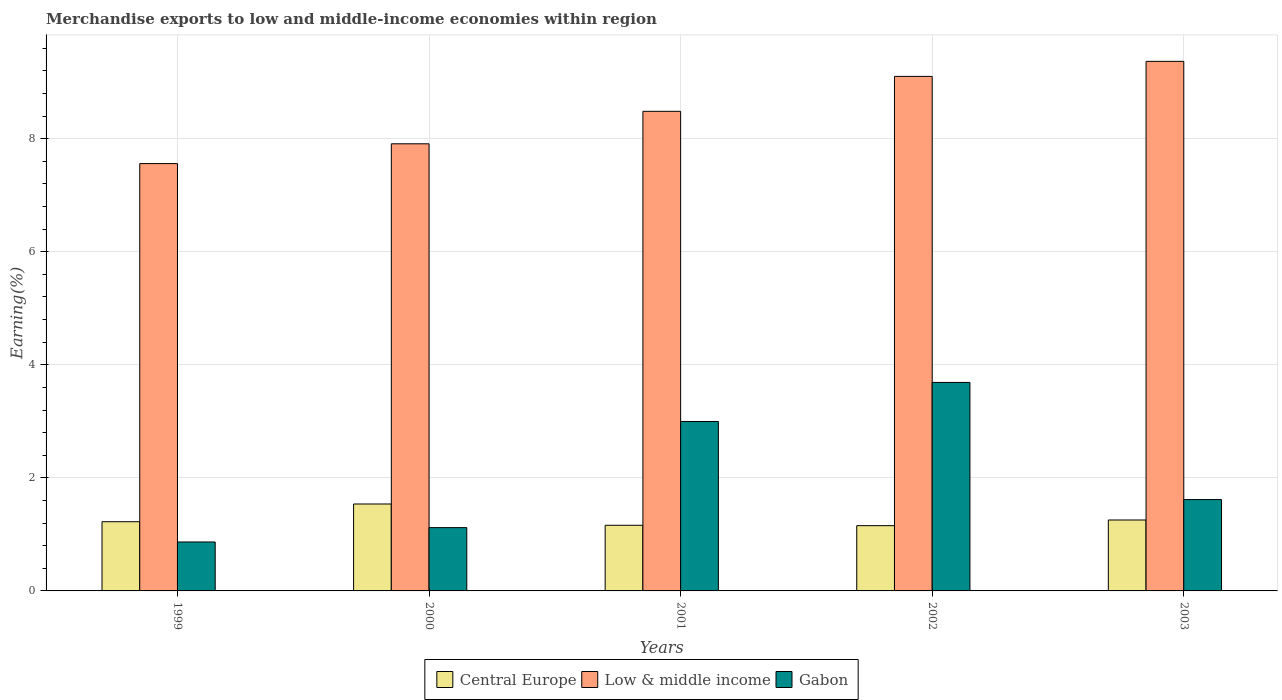How many groups of bars are there?
Your response must be concise. 5. Are the number of bars per tick equal to the number of legend labels?
Give a very brief answer. Yes. Are the number of bars on each tick of the X-axis equal?
Make the answer very short. Yes. How many bars are there on the 1st tick from the left?
Make the answer very short. 3. How many bars are there on the 3rd tick from the right?
Offer a terse response. 3. What is the label of the 1st group of bars from the left?
Keep it short and to the point. 1999. What is the percentage of amount earned from merchandise exports in Gabon in 1999?
Provide a short and direct response. 0.87. Across all years, what is the maximum percentage of amount earned from merchandise exports in Low & middle income?
Give a very brief answer. 9.37. Across all years, what is the minimum percentage of amount earned from merchandise exports in Gabon?
Provide a short and direct response. 0.87. In which year was the percentage of amount earned from merchandise exports in Gabon minimum?
Provide a short and direct response. 1999. What is the total percentage of amount earned from merchandise exports in Low & middle income in the graph?
Your answer should be compact. 42.42. What is the difference between the percentage of amount earned from merchandise exports in Low & middle income in 1999 and that in 2003?
Provide a succinct answer. -1.81. What is the difference between the percentage of amount earned from merchandise exports in Gabon in 2002 and the percentage of amount earned from merchandise exports in Central Europe in 1999?
Offer a terse response. 2.46. What is the average percentage of amount earned from merchandise exports in Low & middle income per year?
Offer a very short reply. 8.48. In the year 2000, what is the difference between the percentage of amount earned from merchandise exports in Low & middle income and percentage of amount earned from merchandise exports in Central Europe?
Give a very brief answer. 6.37. What is the ratio of the percentage of amount earned from merchandise exports in Gabon in 2000 to that in 2002?
Make the answer very short. 0.3. Is the percentage of amount earned from merchandise exports in Central Europe in 1999 less than that in 2000?
Make the answer very short. Yes. What is the difference between the highest and the second highest percentage of amount earned from merchandise exports in Central Europe?
Provide a short and direct response. 0.28. What is the difference between the highest and the lowest percentage of amount earned from merchandise exports in Gabon?
Provide a short and direct response. 2.82. What does the 1st bar from the right in 2003 represents?
Your answer should be compact. Gabon. Is it the case that in every year, the sum of the percentage of amount earned from merchandise exports in Central Europe and percentage of amount earned from merchandise exports in Low & middle income is greater than the percentage of amount earned from merchandise exports in Gabon?
Make the answer very short. Yes. How many bars are there?
Provide a succinct answer. 15. Does the graph contain grids?
Ensure brevity in your answer.  Yes. How many legend labels are there?
Give a very brief answer. 3. What is the title of the graph?
Keep it short and to the point. Merchandise exports to low and middle-income economies within region. Does "Bolivia" appear as one of the legend labels in the graph?
Ensure brevity in your answer.  No. What is the label or title of the X-axis?
Your answer should be compact. Years. What is the label or title of the Y-axis?
Provide a short and direct response. Earning(%). What is the Earning(%) in Central Europe in 1999?
Your response must be concise. 1.22. What is the Earning(%) in Low & middle income in 1999?
Your answer should be compact. 7.56. What is the Earning(%) of Gabon in 1999?
Give a very brief answer. 0.87. What is the Earning(%) of Central Europe in 2000?
Offer a very short reply. 1.54. What is the Earning(%) of Low & middle income in 2000?
Provide a succinct answer. 7.91. What is the Earning(%) in Gabon in 2000?
Give a very brief answer. 1.12. What is the Earning(%) in Central Europe in 2001?
Provide a short and direct response. 1.16. What is the Earning(%) of Low & middle income in 2001?
Offer a terse response. 8.48. What is the Earning(%) in Gabon in 2001?
Provide a succinct answer. 3. What is the Earning(%) in Central Europe in 2002?
Your answer should be very brief. 1.15. What is the Earning(%) of Low & middle income in 2002?
Provide a succinct answer. 9.1. What is the Earning(%) of Gabon in 2002?
Your response must be concise. 3.69. What is the Earning(%) in Central Europe in 2003?
Your response must be concise. 1.25. What is the Earning(%) in Low & middle income in 2003?
Keep it short and to the point. 9.37. What is the Earning(%) of Gabon in 2003?
Your response must be concise. 1.62. Across all years, what is the maximum Earning(%) in Central Europe?
Offer a very short reply. 1.54. Across all years, what is the maximum Earning(%) of Low & middle income?
Ensure brevity in your answer.  9.37. Across all years, what is the maximum Earning(%) of Gabon?
Offer a terse response. 3.69. Across all years, what is the minimum Earning(%) of Central Europe?
Provide a succinct answer. 1.15. Across all years, what is the minimum Earning(%) of Low & middle income?
Provide a short and direct response. 7.56. Across all years, what is the minimum Earning(%) of Gabon?
Provide a succinct answer. 0.87. What is the total Earning(%) in Central Europe in the graph?
Give a very brief answer. 6.33. What is the total Earning(%) in Low & middle income in the graph?
Your answer should be very brief. 42.42. What is the total Earning(%) of Gabon in the graph?
Your response must be concise. 10.29. What is the difference between the Earning(%) of Central Europe in 1999 and that in 2000?
Provide a succinct answer. -0.31. What is the difference between the Earning(%) of Low & middle income in 1999 and that in 2000?
Ensure brevity in your answer.  -0.35. What is the difference between the Earning(%) of Gabon in 1999 and that in 2000?
Provide a succinct answer. -0.25. What is the difference between the Earning(%) of Central Europe in 1999 and that in 2001?
Offer a terse response. 0.06. What is the difference between the Earning(%) in Low & middle income in 1999 and that in 2001?
Your answer should be compact. -0.92. What is the difference between the Earning(%) of Gabon in 1999 and that in 2001?
Your response must be concise. -2.13. What is the difference between the Earning(%) of Central Europe in 1999 and that in 2002?
Offer a terse response. 0.07. What is the difference between the Earning(%) of Low & middle income in 1999 and that in 2002?
Provide a short and direct response. -1.54. What is the difference between the Earning(%) of Gabon in 1999 and that in 2002?
Offer a terse response. -2.82. What is the difference between the Earning(%) of Central Europe in 1999 and that in 2003?
Your answer should be very brief. -0.03. What is the difference between the Earning(%) of Low & middle income in 1999 and that in 2003?
Offer a terse response. -1.81. What is the difference between the Earning(%) in Gabon in 1999 and that in 2003?
Offer a terse response. -0.75. What is the difference between the Earning(%) in Central Europe in 2000 and that in 2001?
Your answer should be very brief. 0.38. What is the difference between the Earning(%) in Low & middle income in 2000 and that in 2001?
Give a very brief answer. -0.57. What is the difference between the Earning(%) of Gabon in 2000 and that in 2001?
Provide a short and direct response. -1.88. What is the difference between the Earning(%) in Central Europe in 2000 and that in 2002?
Your answer should be very brief. 0.38. What is the difference between the Earning(%) in Low & middle income in 2000 and that in 2002?
Offer a very short reply. -1.19. What is the difference between the Earning(%) of Gabon in 2000 and that in 2002?
Give a very brief answer. -2.57. What is the difference between the Earning(%) of Central Europe in 2000 and that in 2003?
Provide a succinct answer. 0.28. What is the difference between the Earning(%) of Low & middle income in 2000 and that in 2003?
Keep it short and to the point. -1.46. What is the difference between the Earning(%) in Gabon in 2000 and that in 2003?
Your answer should be compact. -0.5. What is the difference between the Earning(%) of Central Europe in 2001 and that in 2002?
Your answer should be very brief. 0.01. What is the difference between the Earning(%) of Low & middle income in 2001 and that in 2002?
Your answer should be very brief. -0.62. What is the difference between the Earning(%) in Gabon in 2001 and that in 2002?
Your response must be concise. -0.69. What is the difference between the Earning(%) of Central Europe in 2001 and that in 2003?
Offer a very short reply. -0.09. What is the difference between the Earning(%) in Low & middle income in 2001 and that in 2003?
Provide a succinct answer. -0.88. What is the difference between the Earning(%) in Gabon in 2001 and that in 2003?
Your response must be concise. 1.38. What is the difference between the Earning(%) in Central Europe in 2002 and that in 2003?
Make the answer very short. -0.1. What is the difference between the Earning(%) of Low & middle income in 2002 and that in 2003?
Keep it short and to the point. -0.27. What is the difference between the Earning(%) in Gabon in 2002 and that in 2003?
Your answer should be very brief. 2.07. What is the difference between the Earning(%) in Central Europe in 1999 and the Earning(%) in Low & middle income in 2000?
Your answer should be compact. -6.68. What is the difference between the Earning(%) of Central Europe in 1999 and the Earning(%) of Gabon in 2000?
Ensure brevity in your answer.  0.1. What is the difference between the Earning(%) in Low & middle income in 1999 and the Earning(%) in Gabon in 2000?
Your answer should be very brief. 6.44. What is the difference between the Earning(%) of Central Europe in 1999 and the Earning(%) of Low & middle income in 2001?
Make the answer very short. -7.26. What is the difference between the Earning(%) of Central Europe in 1999 and the Earning(%) of Gabon in 2001?
Offer a very short reply. -1.77. What is the difference between the Earning(%) of Low & middle income in 1999 and the Earning(%) of Gabon in 2001?
Your answer should be very brief. 4.56. What is the difference between the Earning(%) of Central Europe in 1999 and the Earning(%) of Low & middle income in 2002?
Your answer should be very brief. -7.88. What is the difference between the Earning(%) in Central Europe in 1999 and the Earning(%) in Gabon in 2002?
Offer a terse response. -2.46. What is the difference between the Earning(%) in Low & middle income in 1999 and the Earning(%) in Gabon in 2002?
Your response must be concise. 3.87. What is the difference between the Earning(%) in Central Europe in 1999 and the Earning(%) in Low & middle income in 2003?
Keep it short and to the point. -8.14. What is the difference between the Earning(%) of Central Europe in 1999 and the Earning(%) of Gabon in 2003?
Provide a succinct answer. -0.39. What is the difference between the Earning(%) in Low & middle income in 1999 and the Earning(%) in Gabon in 2003?
Your answer should be very brief. 5.94. What is the difference between the Earning(%) of Central Europe in 2000 and the Earning(%) of Low & middle income in 2001?
Offer a very short reply. -6.95. What is the difference between the Earning(%) in Central Europe in 2000 and the Earning(%) in Gabon in 2001?
Your answer should be very brief. -1.46. What is the difference between the Earning(%) of Low & middle income in 2000 and the Earning(%) of Gabon in 2001?
Your answer should be compact. 4.91. What is the difference between the Earning(%) in Central Europe in 2000 and the Earning(%) in Low & middle income in 2002?
Make the answer very short. -7.56. What is the difference between the Earning(%) of Central Europe in 2000 and the Earning(%) of Gabon in 2002?
Keep it short and to the point. -2.15. What is the difference between the Earning(%) in Low & middle income in 2000 and the Earning(%) in Gabon in 2002?
Provide a short and direct response. 4.22. What is the difference between the Earning(%) in Central Europe in 2000 and the Earning(%) in Low & middle income in 2003?
Your response must be concise. -7.83. What is the difference between the Earning(%) in Central Europe in 2000 and the Earning(%) in Gabon in 2003?
Ensure brevity in your answer.  -0.08. What is the difference between the Earning(%) in Low & middle income in 2000 and the Earning(%) in Gabon in 2003?
Make the answer very short. 6.29. What is the difference between the Earning(%) in Central Europe in 2001 and the Earning(%) in Low & middle income in 2002?
Offer a very short reply. -7.94. What is the difference between the Earning(%) of Central Europe in 2001 and the Earning(%) of Gabon in 2002?
Give a very brief answer. -2.53. What is the difference between the Earning(%) in Low & middle income in 2001 and the Earning(%) in Gabon in 2002?
Provide a short and direct response. 4.8. What is the difference between the Earning(%) of Central Europe in 2001 and the Earning(%) of Low & middle income in 2003?
Provide a succinct answer. -8.21. What is the difference between the Earning(%) in Central Europe in 2001 and the Earning(%) in Gabon in 2003?
Provide a short and direct response. -0.45. What is the difference between the Earning(%) of Low & middle income in 2001 and the Earning(%) of Gabon in 2003?
Provide a short and direct response. 6.87. What is the difference between the Earning(%) in Central Europe in 2002 and the Earning(%) in Low & middle income in 2003?
Ensure brevity in your answer.  -8.21. What is the difference between the Earning(%) in Central Europe in 2002 and the Earning(%) in Gabon in 2003?
Keep it short and to the point. -0.46. What is the difference between the Earning(%) of Low & middle income in 2002 and the Earning(%) of Gabon in 2003?
Make the answer very short. 7.49. What is the average Earning(%) in Central Europe per year?
Your response must be concise. 1.27. What is the average Earning(%) in Low & middle income per year?
Your answer should be very brief. 8.48. What is the average Earning(%) in Gabon per year?
Your answer should be very brief. 2.06. In the year 1999, what is the difference between the Earning(%) of Central Europe and Earning(%) of Low & middle income?
Give a very brief answer. -6.33. In the year 1999, what is the difference between the Earning(%) of Central Europe and Earning(%) of Gabon?
Offer a terse response. 0.36. In the year 1999, what is the difference between the Earning(%) of Low & middle income and Earning(%) of Gabon?
Your response must be concise. 6.69. In the year 2000, what is the difference between the Earning(%) of Central Europe and Earning(%) of Low & middle income?
Provide a short and direct response. -6.37. In the year 2000, what is the difference between the Earning(%) of Central Europe and Earning(%) of Gabon?
Offer a terse response. 0.42. In the year 2000, what is the difference between the Earning(%) in Low & middle income and Earning(%) in Gabon?
Your response must be concise. 6.79. In the year 2001, what is the difference between the Earning(%) of Central Europe and Earning(%) of Low & middle income?
Make the answer very short. -7.32. In the year 2001, what is the difference between the Earning(%) in Central Europe and Earning(%) in Gabon?
Give a very brief answer. -1.84. In the year 2001, what is the difference between the Earning(%) in Low & middle income and Earning(%) in Gabon?
Make the answer very short. 5.49. In the year 2002, what is the difference between the Earning(%) of Central Europe and Earning(%) of Low & middle income?
Your answer should be compact. -7.95. In the year 2002, what is the difference between the Earning(%) of Central Europe and Earning(%) of Gabon?
Your answer should be compact. -2.53. In the year 2002, what is the difference between the Earning(%) in Low & middle income and Earning(%) in Gabon?
Your answer should be compact. 5.41. In the year 2003, what is the difference between the Earning(%) in Central Europe and Earning(%) in Low & middle income?
Offer a terse response. -8.11. In the year 2003, what is the difference between the Earning(%) of Central Europe and Earning(%) of Gabon?
Your answer should be compact. -0.36. In the year 2003, what is the difference between the Earning(%) in Low & middle income and Earning(%) in Gabon?
Offer a terse response. 7.75. What is the ratio of the Earning(%) in Central Europe in 1999 to that in 2000?
Your response must be concise. 0.8. What is the ratio of the Earning(%) in Low & middle income in 1999 to that in 2000?
Make the answer very short. 0.96. What is the ratio of the Earning(%) in Gabon in 1999 to that in 2000?
Make the answer very short. 0.77. What is the ratio of the Earning(%) of Central Europe in 1999 to that in 2001?
Make the answer very short. 1.05. What is the ratio of the Earning(%) of Low & middle income in 1999 to that in 2001?
Keep it short and to the point. 0.89. What is the ratio of the Earning(%) of Gabon in 1999 to that in 2001?
Ensure brevity in your answer.  0.29. What is the ratio of the Earning(%) of Central Europe in 1999 to that in 2002?
Keep it short and to the point. 1.06. What is the ratio of the Earning(%) in Low & middle income in 1999 to that in 2002?
Provide a short and direct response. 0.83. What is the ratio of the Earning(%) of Gabon in 1999 to that in 2002?
Keep it short and to the point. 0.23. What is the ratio of the Earning(%) in Central Europe in 1999 to that in 2003?
Your answer should be very brief. 0.98. What is the ratio of the Earning(%) in Low & middle income in 1999 to that in 2003?
Provide a short and direct response. 0.81. What is the ratio of the Earning(%) of Gabon in 1999 to that in 2003?
Make the answer very short. 0.54. What is the ratio of the Earning(%) of Central Europe in 2000 to that in 2001?
Offer a terse response. 1.32. What is the ratio of the Earning(%) in Low & middle income in 2000 to that in 2001?
Your response must be concise. 0.93. What is the ratio of the Earning(%) of Gabon in 2000 to that in 2001?
Keep it short and to the point. 0.37. What is the ratio of the Earning(%) of Central Europe in 2000 to that in 2002?
Your answer should be very brief. 1.33. What is the ratio of the Earning(%) in Low & middle income in 2000 to that in 2002?
Your response must be concise. 0.87. What is the ratio of the Earning(%) of Gabon in 2000 to that in 2002?
Ensure brevity in your answer.  0.3. What is the ratio of the Earning(%) of Central Europe in 2000 to that in 2003?
Your answer should be compact. 1.23. What is the ratio of the Earning(%) in Low & middle income in 2000 to that in 2003?
Keep it short and to the point. 0.84. What is the ratio of the Earning(%) in Gabon in 2000 to that in 2003?
Provide a succinct answer. 0.69. What is the ratio of the Earning(%) of Central Europe in 2001 to that in 2002?
Offer a very short reply. 1.01. What is the ratio of the Earning(%) in Low & middle income in 2001 to that in 2002?
Provide a short and direct response. 0.93. What is the ratio of the Earning(%) of Gabon in 2001 to that in 2002?
Make the answer very short. 0.81. What is the ratio of the Earning(%) in Central Europe in 2001 to that in 2003?
Give a very brief answer. 0.93. What is the ratio of the Earning(%) in Low & middle income in 2001 to that in 2003?
Offer a terse response. 0.91. What is the ratio of the Earning(%) in Gabon in 2001 to that in 2003?
Offer a very short reply. 1.85. What is the ratio of the Earning(%) of Central Europe in 2002 to that in 2003?
Give a very brief answer. 0.92. What is the ratio of the Earning(%) in Low & middle income in 2002 to that in 2003?
Ensure brevity in your answer.  0.97. What is the ratio of the Earning(%) of Gabon in 2002 to that in 2003?
Your response must be concise. 2.28. What is the difference between the highest and the second highest Earning(%) in Central Europe?
Make the answer very short. 0.28. What is the difference between the highest and the second highest Earning(%) in Low & middle income?
Offer a very short reply. 0.27. What is the difference between the highest and the second highest Earning(%) of Gabon?
Ensure brevity in your answer.  0.69. What is the difference between the highest and the lowest Earning(%) of Central Europe?
Provide a short and direct response. 0.38. What is the difference between the highest and the lowest Earning(%) in Low & middle income?
Offer a terse response. 1.81. What is the difference between the highest and the lowest Earning(%) of Gabon?
Ensure brevity in your answer.  2.82. 